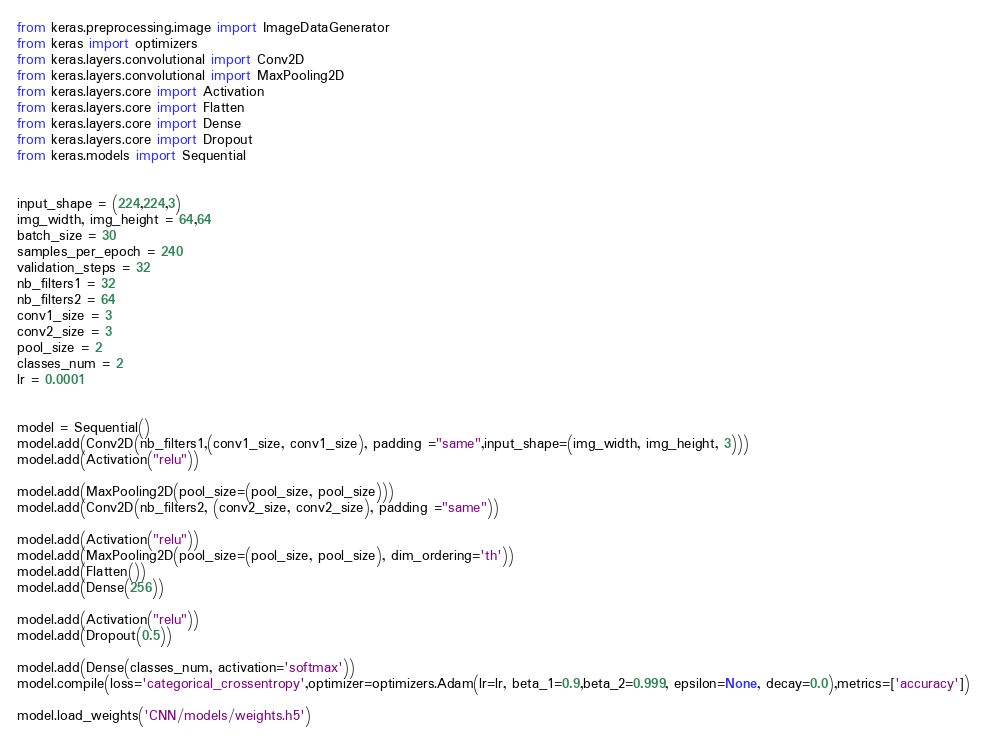Convert code to text. <code><loc_0><loc_0><loc_500><loc_500><_Python_>
from keras.preprocessing.image import ImageDataGenerator
from keras import optimizers
from keras.layers.convolutional import Conv2D
from keras.layers.convolutional import MaxPooling2D
from keras.layers.core import Activation
from keras.layers.core import Flatten
from keras.layers.core import Dense
from keras.layers.core import Dropout
from keras.models import Sequential 


input_shape = (224,224,3)
img_width, img_height = 64,64
batch_size = 30
samples_per_epoch = 240
validation_steps = 32
nb_filters1 = 32
nb_filters2 = 64
conv1_size = 3
conv2_size = 3
pool_size = 2
classes_num = 2
lr = 0.0001


model = Sequential()
model.add(Conv2D(nb_filters1,(conv1_size, conv1_size), padding ="same",input_shape=(img_width, img_height, 3)))
model.add(Activation("relu"))
model.add(MaxPooling2D(pool_size=(pool_size, pool_size)))
model.add(Conv2D(nb_filters2, (conv2_size, conv2_size), padding ="same"))
model.add(Activation("relu"))
model.add(MaxPooling2D(pool_size=(pool_size, pool_size), dim_ordering='th'))
model.add(Flatten())
model.add(Dense(256))
model.add(Activation("relu"))
model.add(Dropout(0.5))
model.add(Dense(classes_num, activation='softmax'))
model.compile(loss='categorical_crossentropy',optimizer=optimizers.Adam(lr=lr, beta_1=0.9,beta_2=0.999, epsilon=None, decay=0.0),metrics=['accuracy'])
model.load_weights('CNN/models/weights.h5')
</code> 